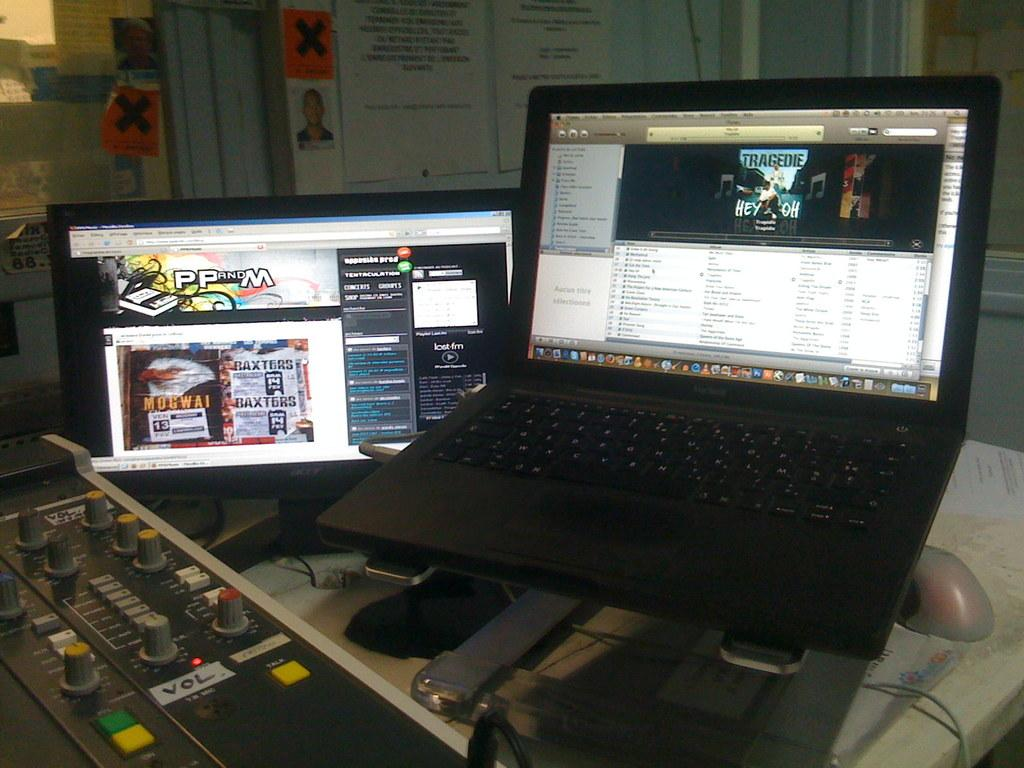<image>
Give a short and clear explanation of the subsequent image. A desktop monitor says PP and M at the top of the screen. 